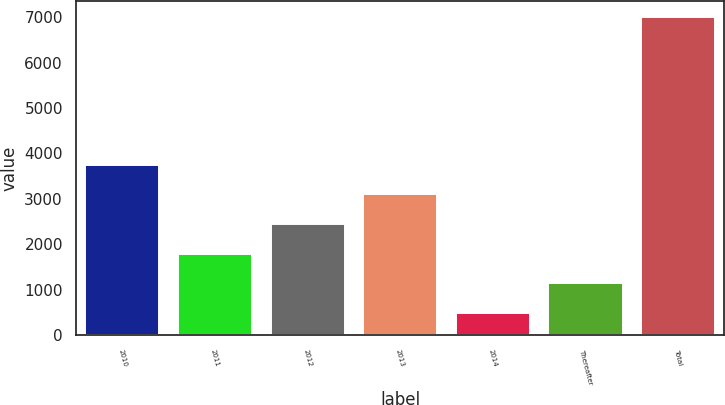Convert chart to OTSL. <chart><loc_0><loc_0><loc_500><loc_500><bar_chart><fcel>2010<fcel>2011<fcel>2012<fcel>2013<fcel>2014<fcel>Thereafter<fcel>Total<nl><fcel>3750<fcel>1800<fcel>2450<fcel>3100<fcel>500<fcel>1150<fcel>7000<nl></chart> 